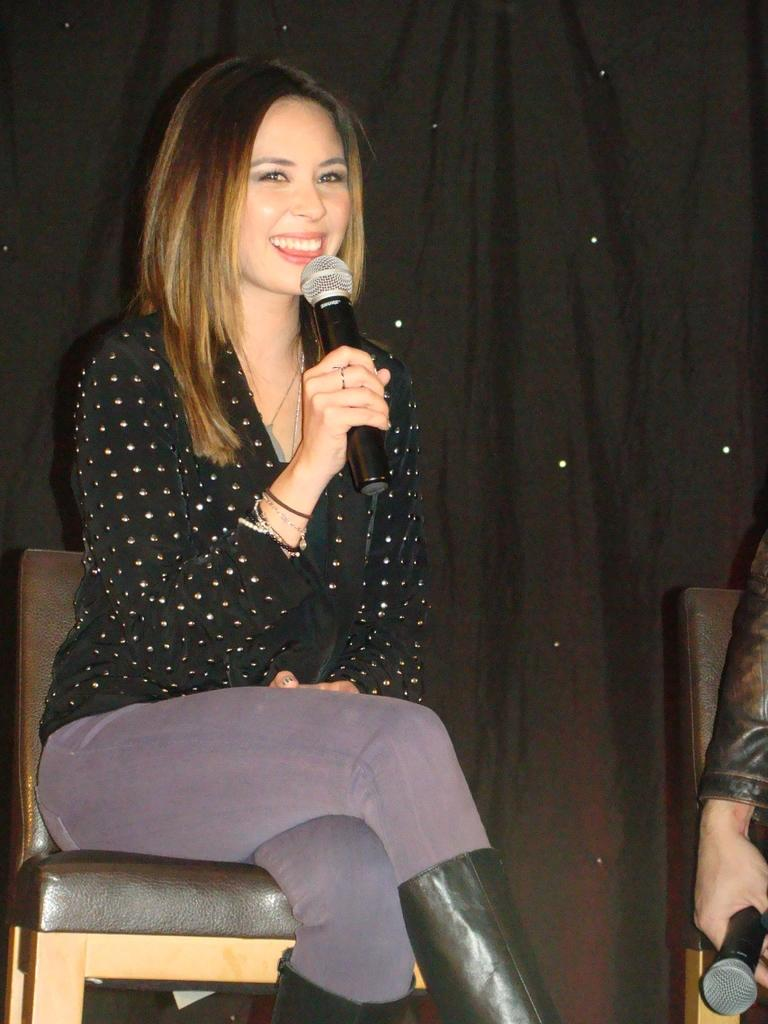Who is the main subject in the image? There is a woman in the image. What is the woman doing in the image? The woman is sitting on a chair and talking. What object is the woman holding in the image? The woman is holding a microphone. What can be seen in the background of the image? There is a curtain in the background of the image. Can you describe the person on the left side of the image? There is a person holding a microphone on the left side of the image. What type of sticks are being used by the woman in the image? There are no sticks present in the image; the woman is holding a microphone. 